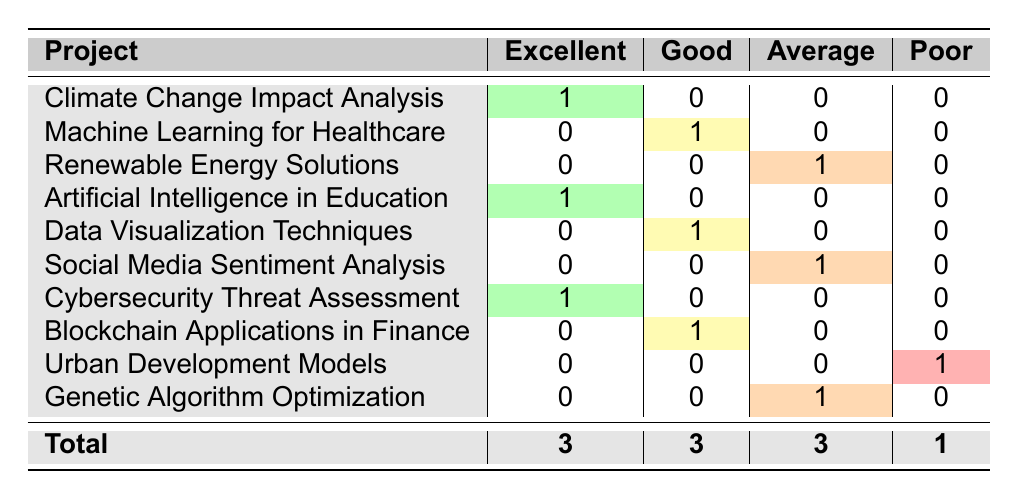What is the total number of projects rated as Excellent? The table shows three projects with the rating Excellent: Climate Change Impact Analysis, Artificial Intelligence in Education, and Cybersecurity Threat Assessment. Thus, summing these, we find a total of 3 projects rated as Excellent.
Answer: 3 Which project received a Poor rating? The table indicates that the Urban Development Models project received a Poor rating, as it is the only one listed under that category.
Answer: Urban Development Models How many projects received a Good rating? By looking at the table, we can see that three projects received a Good rating: Machine Learning for Healthcare, Data Visualization Techniques, and Blockchain Applications in Finance. Therefore, the total is 3.
Answer: 3 Are there more projects rated as Average than as Poor? The table shows that there are three projects rated as Average (Renewable Energy Solutions, Social Media Sentiment Analysis, and Genetic Algorithm Optimization) and one project rated as Poor (Urban Development Models). Since 3 is greater than 1, the statement is true.
Answer: Yes What is the percentage of projects rated as Excellent out of the total number of projects? To find the percentage, we first note there are a total of 10 projects listed. The number of projects rated as Excellent is 3. The percentage is calculated by (3/10) * 100, which results in 30%.
Answer: 30% Which feedback rating is received by the most number of projects? Upon inspecting the counts in the table, we see that the ratings Excellent, Good, and Average each have 3 instances, while Poor has 1 instance. Therefore, the feedback ratings Excellent, Good, and Average are tied for the most received ratings among projects based on their counts.
Answer: Excellent, Good, Average What is the difference between the number of projects rated as Average and Good? The table shows 3 projects rated as Average and also 3 projects rated as Good. The difference is calculated as 3 - 3, which equals 0.
Answer: 0 Count how many projects each student received a feedback rating of Excellent. The table provides information on three students who received an Excellent rating: Alice Johnson, Liam Brown, and Emma Martinez. Hence, the total count is 3.
Answer: 3 